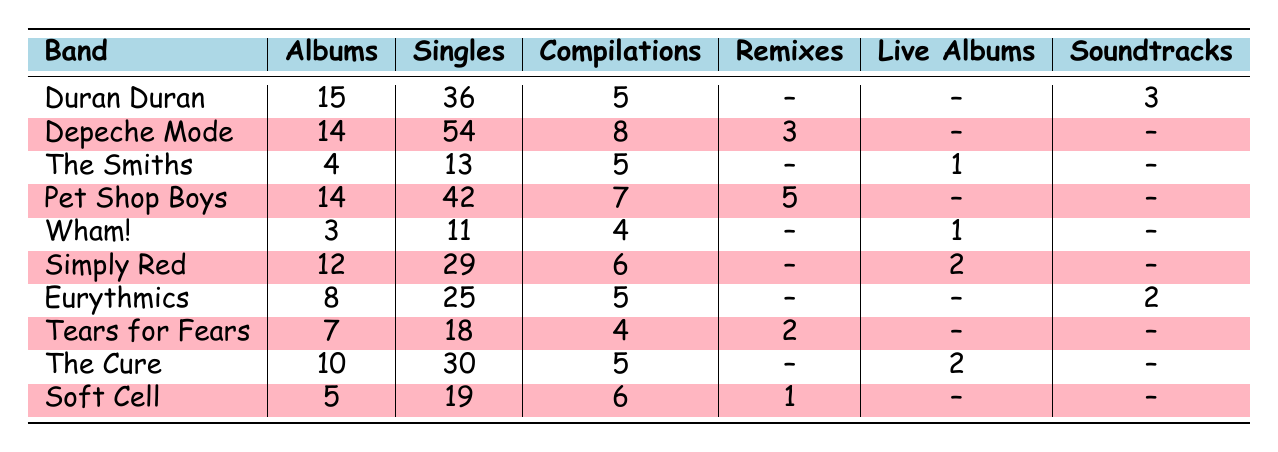What band has the most albums? Duran Duran has 15 albums, which is more than any other band listed in the table.
Answer: Duran Duran Which band has the least number of singles? Wham! has the least number of singles with 11, while the others have more.
Answer: Wham! How many total compilations do all bands have combined? The total number of compilations can be calculated by adding the compilations for each band: 5 + 8 + 5 + 7 + 4 + 6 + 5 + 4 + 6 + 0 = 60.
Answer: 60 Which band has more albums, Depeche Mode or Pet Shop Boys? Depeche Mode has 14 albums while Pet Shop Boys also has 14, meaning they are equal.
Answer: Equal What is the difference in the number of singles between Duran Duran and Tears for Fears? Duran Duran has 36 singles and Tears for Fears has 18 singles. The difference is 36 - 18 = 18.
Answer: 18 Does any band have a higher number of compilations than Pet Shop Boys? Pet Shop Boys has 7 compilations and Depeche Mode has 8, which is more than Pet Shop Boys.
Answer: Yes How many artists have released more than 30 singles? Duran Duran (36), Depeche Mode (54), and Pet Shop Boys (42) have more than 30 singles, which is a total of 3 artists.
Answer: 3 What is the average number of albums released by the bands listed? To find the average, sum the albums (15 + 14 + 4 + 14 + 3 + 12 + 8 + 7 + 10 + 5 = 92) and divide by the number of bands (10), resulting in 92/10 = 9.2.
Answer: 9.2 Which band has the most diverse discography considering different types such as singles, albums, and compilations? Reviewing the table, Depeche Mode has the highest counts for singles (54), albums (14), compilations (8), and remixes (3), indicating a diverse music catalog.
Answer: Depeche Mode What is the total number of albums and singles by Simply Red? Simply Red has 12 albums and 29 singles, adding these gives a total of 12 + 29 = 41.
Answer: 41 